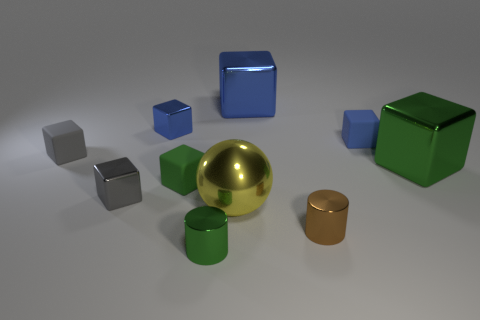What number of tiny rubber things are to the right of the small rubber block that is behind the gray matte cube that is behind the green rubber object?
Keep it short and to the point. 0. Do the blue rubber object and the tiny gray metal thing have the same shape?
Make the answer very short. Yes. Are there any green metal things of the same shape as the tiny gray rubber thing?
Keep it short and to the point. Yes. There is a green metallic object that is the same size as the brown object; what is its shape?
Provide a short and direct response. Cylinder. The green block on the left side of the green metal thing in front of the green metallic object behind the small green cylinder is made of what material?
Your answer should be very brief. Rubber. Is the size of the ball the same as the green metal cube?
Make the answer very short. Yes. What material is the large yellow ball?
Your answer should be very brief. Metal. Does the green object in front of the small brown cylinder have the same shape as the large blue metal thing?
Your answer should be very brief. No. How many things are red metallic objects or blue objects?
Provide a succinct answer. 3. Do the tiny blue block to the right of the large metallic ball and the yellow ball have the same material?
Your answer should be very brief. No. 